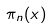Convert formula to latex. <formula><loc_0><loc_0><loc_500><loc_500>\pi _ { n } ( x )</formula> 